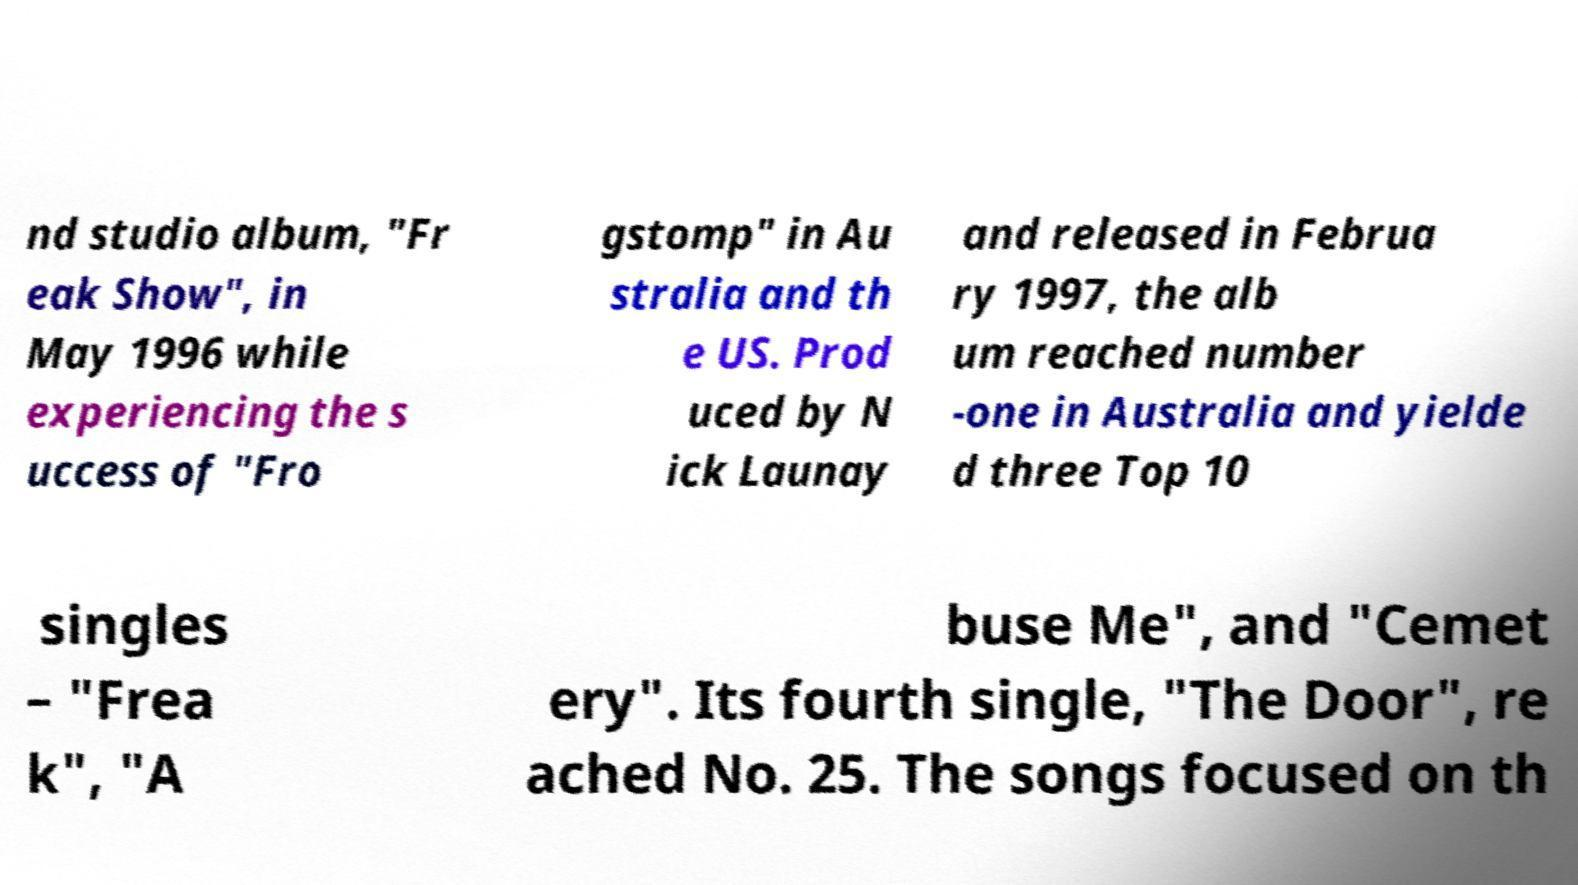Can you accurately transcribe the text from the provided image for me? nd studio album, "Fr eak Show", in May 1996 while experiencing the s uccess of "Fro gstomp" in Au stralia and th e US. Prod uced by N ick Launay and released in Februa ry 1997, the alb um reached number -one in Australia and yielde d three Top 10 singles – "Frea k", "A buse Me", and "Cemet ery". Its fourth single, "The Door", re ached No. 25. The songs focused on th 